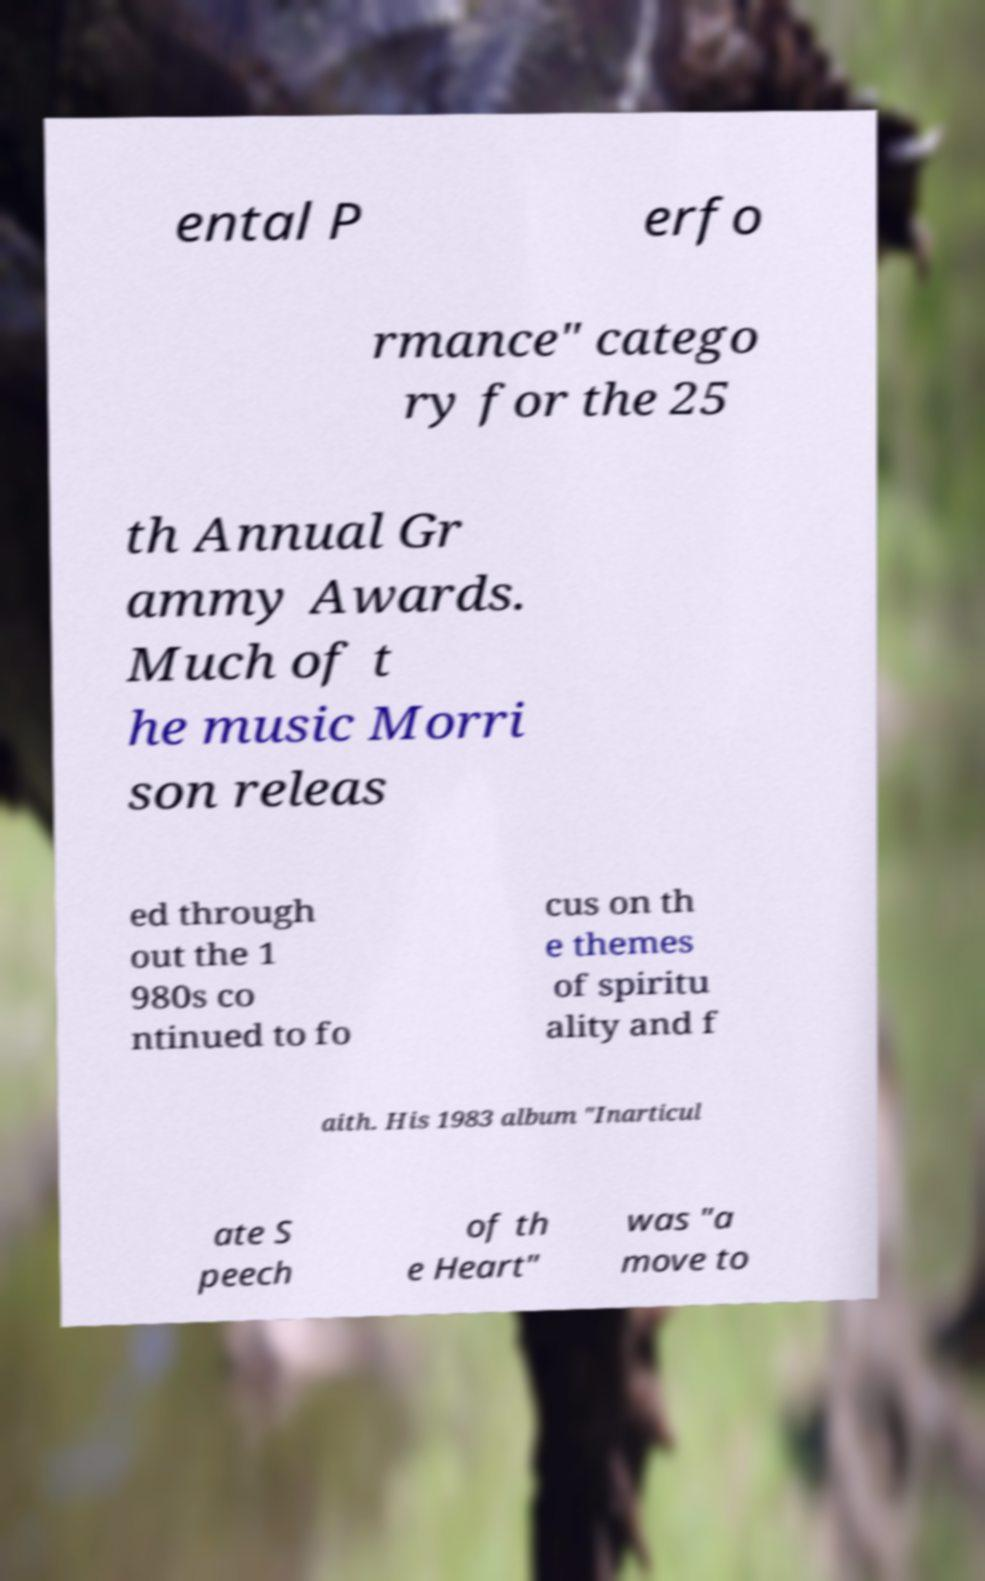What messages or text are displayed in this image? I need them in a readable, typed format. ental P erfo rmance" catego ry for the 25 th Annual Gr ammy Awards. Much of t he music Morri son releas ed through out the 1 980s co ntinued to fo cus on th e themes of spiritu ality and f aith. His 1983 album "Inarticul ate S peech of th e Heart" was "a move to 